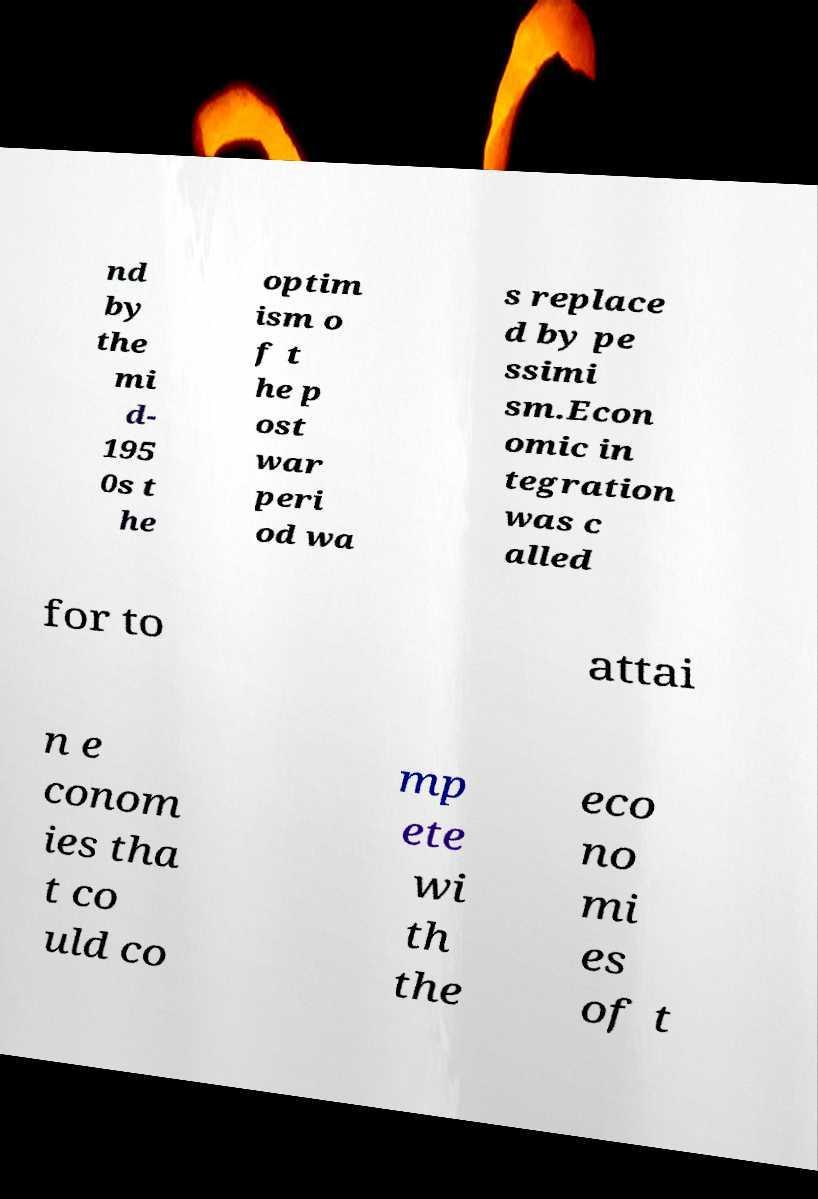Please identify and transcribe the text found in this image. nd by the mi d- 195 0s t he optim ism o f t he p ost war peri od wa s replace d by pe ssimi sm.Econ omic in tegration was c alled for to attai n e conom ies tha t co uld co mp ete wi th the eco no mi es of t 